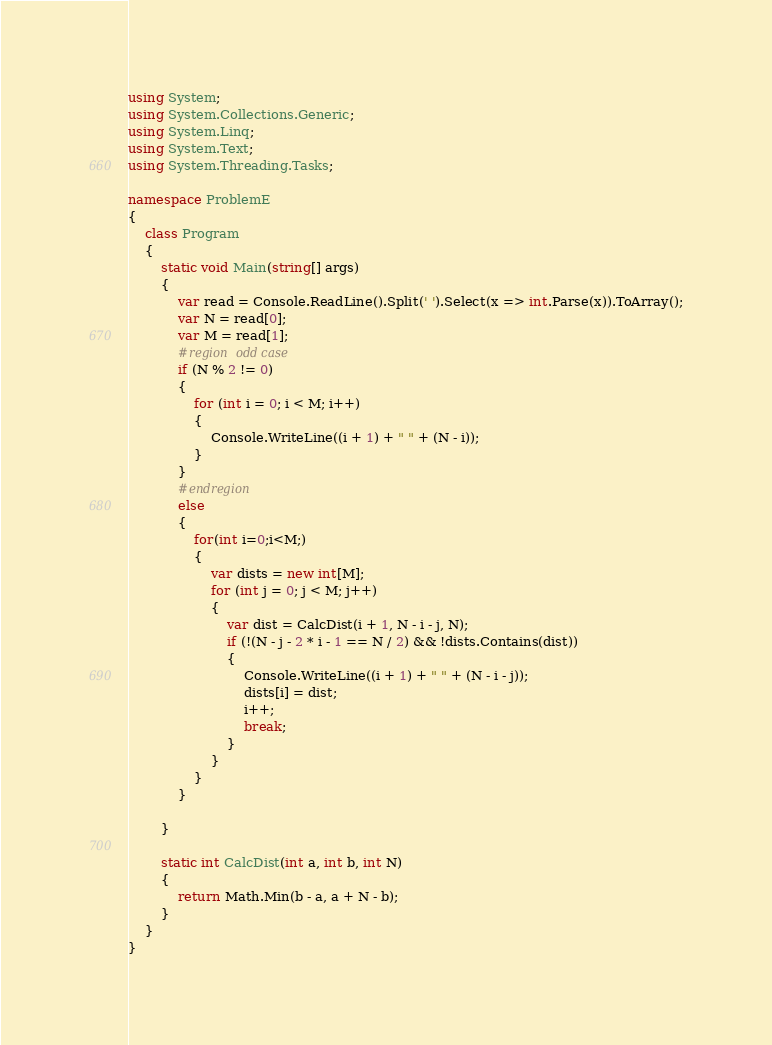Convert code to text. <code><loc_0><loc_0><loc_500><loc_500><_C#_>using System;
using System.Collections.Generic;
using System.Linq;
using System.Text;
using System.Threading.Tasks;

namespace ProblemE
{
    class Program
    {
        static void Main(string[] args)
        {
            var read = Console.ReadLine().Split(' ').Select(x => int.Parse(x)).ToArray();
            var N = read[0];
            var M = read[1];
            #region odd case
            if (N % 2 != 0)
            {
                for (int i = 0; i < M; i++)
                {
                    Console.WriteLine((i + 1) + " " + (N - i));
                }
            }
            #endregion 
            else
            {
                for(int i=0;i<M;)
                {
                    var dists = new int[M];
                    for (int j = 0; j < M; j++)
                    {
                        var dist = CalcDist(i + 1, N - i - j, N);
                        if (!(N - j - 2 * i - 1 == N / 2) && !dists.Contains(dist))
                        {
                            Console.WriteLine((i + 1) + " " + (N - i - j));
                            dists[i] = dist;
                            i++;
                            break;
                        }
                    }
                }
            }

        }

        static int CalcDist(int a, int b, int N)
        {
            return Math.Min(b - a, a + N - b);
        }
    }
}
</code> 